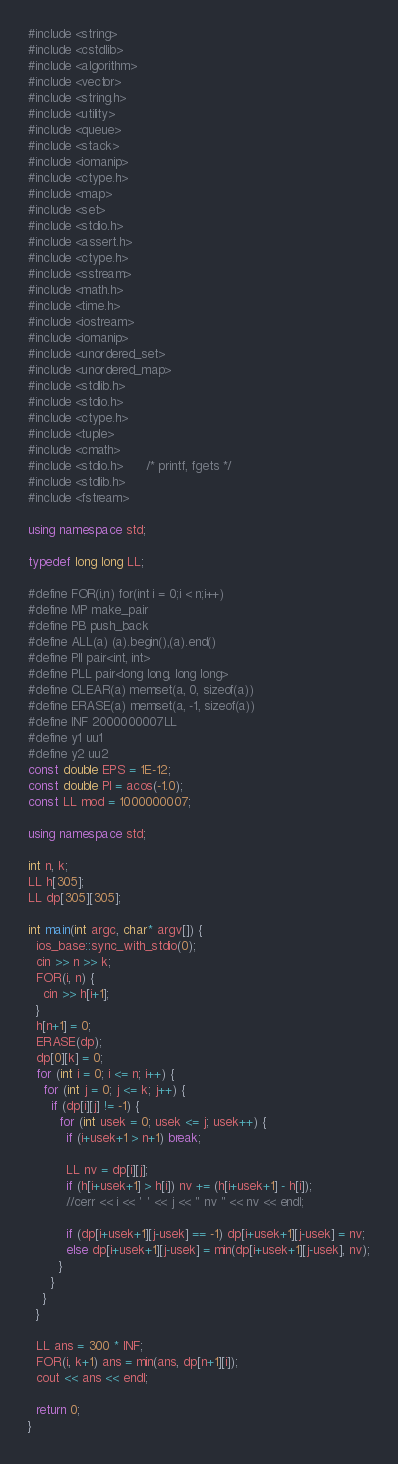Convert code to text. <code><loc_0><loc_0><loc_500><loc_500><_C++_>#include <string>
#include <cstdlib>
#include <algorithm>
#include <vector>
#include <string.h>
#include <utility>
#include <queue>
#include <stack>
#include <iomanip>
#include <ctype.h>
#include <map>
#include <set>
#include <stdio.h>
#include <assert.h>
#include <ctype.h>
#include <sstream>
#include <math.h>
#include <time.h>
#include <iostream>
#include <iomanip>
#include <unordered_set>
#include <unordered_map>
#include <stdlib.h>
#include <stdio.h>
#include <ctype.h>
#include <tuple>
#include <cmath>
#include <stdio.h>      /* printf, fgets */
#include <stdlib.h>
#include <fstream>

using namespace std;

typedef long long LL;

#define FOR(i,n) for(int i = 0;i < n;i++)
#define MP make_pair
#define PB push_back
#define ALL(a) (a).begin(),(a).end()
#define PII pair<int, int>
#define PLL pair<long long, long long>
#define CLEAR(a) memset(a, 0, sizeof(a))
#define ERASE(a) memset(a, -1, sizeof(a))
#define INF 2000000007LL
#define y1 uu1
#define y2 uu2
const double EPS = 1E-12;
const double PI = acos(-1.0);
const LL mod = 1000000007;

using namespace std;

int n, k;
LL h[305];
LL dp[305][305];

int main(int argc, char* argv[]) {
  ios_base::sync_with_stdio(0);
  cin >> n >> k;
  FOR(i, n) {
    cin >> h[i+1];
  }
  h[n+1] = 0;
  ERASE(dp);
  dp[0][k] = 0;
  for (int i = 0; i <= n; i++) {
    for (int j = 0; j <= k; j++) {
      if (dp[i][j] != -1) {
        for (int usek = 0; usek <= j; usek++) {
          if (i+usek+1 > n+1) break;

          LL nv = dp[i][j];
          if (h[i+usek+1] > h[i]) nv += (h[i+usek+1] - h[i]);
          //cerr << i << ' ' << j << " nv " << nv << endl;

          if (dp[i+usek+1][j-usek] == -1) dp[i+usek+1][j-usek] = nv;
          else dp[i+usek+1][j-usek] = min(dp[i+usek+1][j-usek], nv);
        }
      }
    }
  }

  LL ans = 300 * INF;
  FOR(i, k+1) ans = min(ans, dp[n+1][i]);
  cout << ans << endl;

  return 0;
}
</code> 